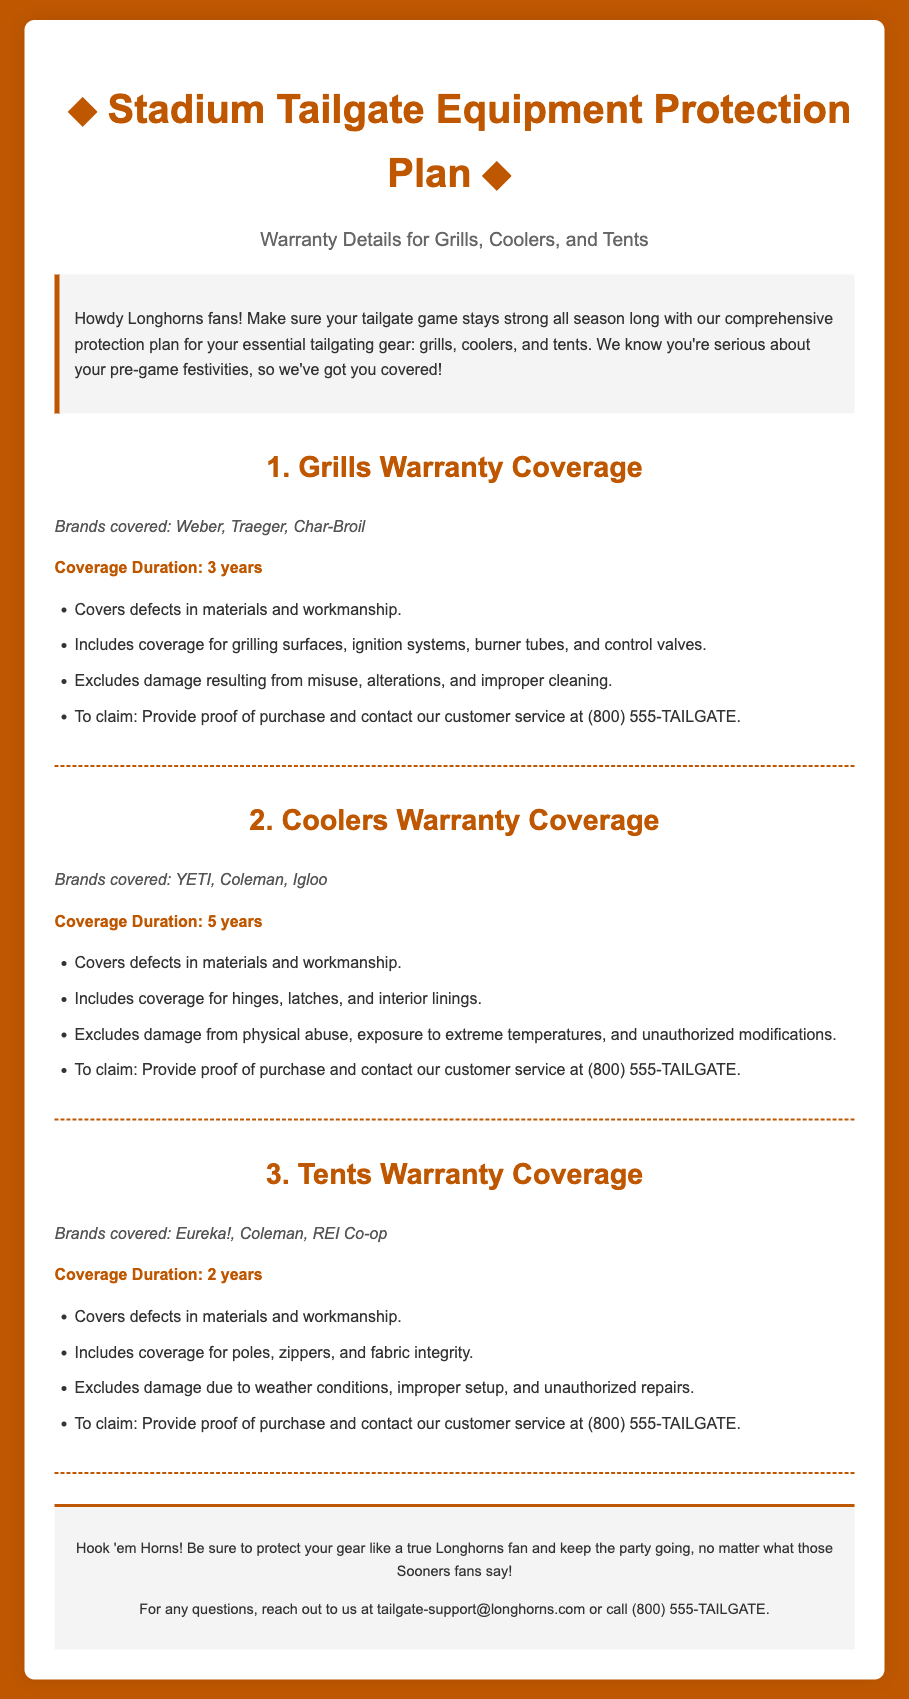What brands are covered for grills? The document lists brands covered for grills including Weber, Traeger, and Char-Broil.
Answer: Weber, Traeger, Char-Broil How long is the coverage duration for coolers? The coverage duration for coolers is specified in the document as 5 years.
Answer: 5 years What should you provide to claim the warranty for tents? The document states that to claim the warranty for tents, one must provide proof of purchase.
Answer: Proof of purchase What types of damage are excluded for grills warranty? The document mentions that damage resulting from misuse, alterations, and improper cleaning is excluded for grills warranty.
Answer: Misuse, alterations, improper cleaning What is the coverage duration for tents? The document specifies that the coverage duration for tents is 2 years.
Answer: 2 years What is the contact number for customer service? The document provides the customer service number as (800) 555-TAILGATE.
Answer: (800) 555-TAILGATE What types of components are covered for coolers? The document includes coverage for hinges, latches, and interior linings in coolers.
Answer: Hinges, latches, interior linings Which brands are specifically covered for tents? The brands specifically covered for tents according to the document are Eureka!, Coleman, and REI Co-op.
Answer: Eureka!, Coleman, REI Co-op What is the warranty duration for grills? The document states that the warranty duration for grills is 3 years.
Answer: 3 years 